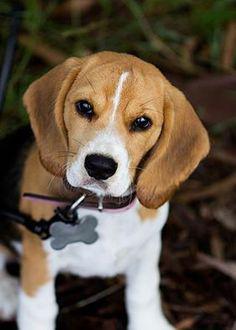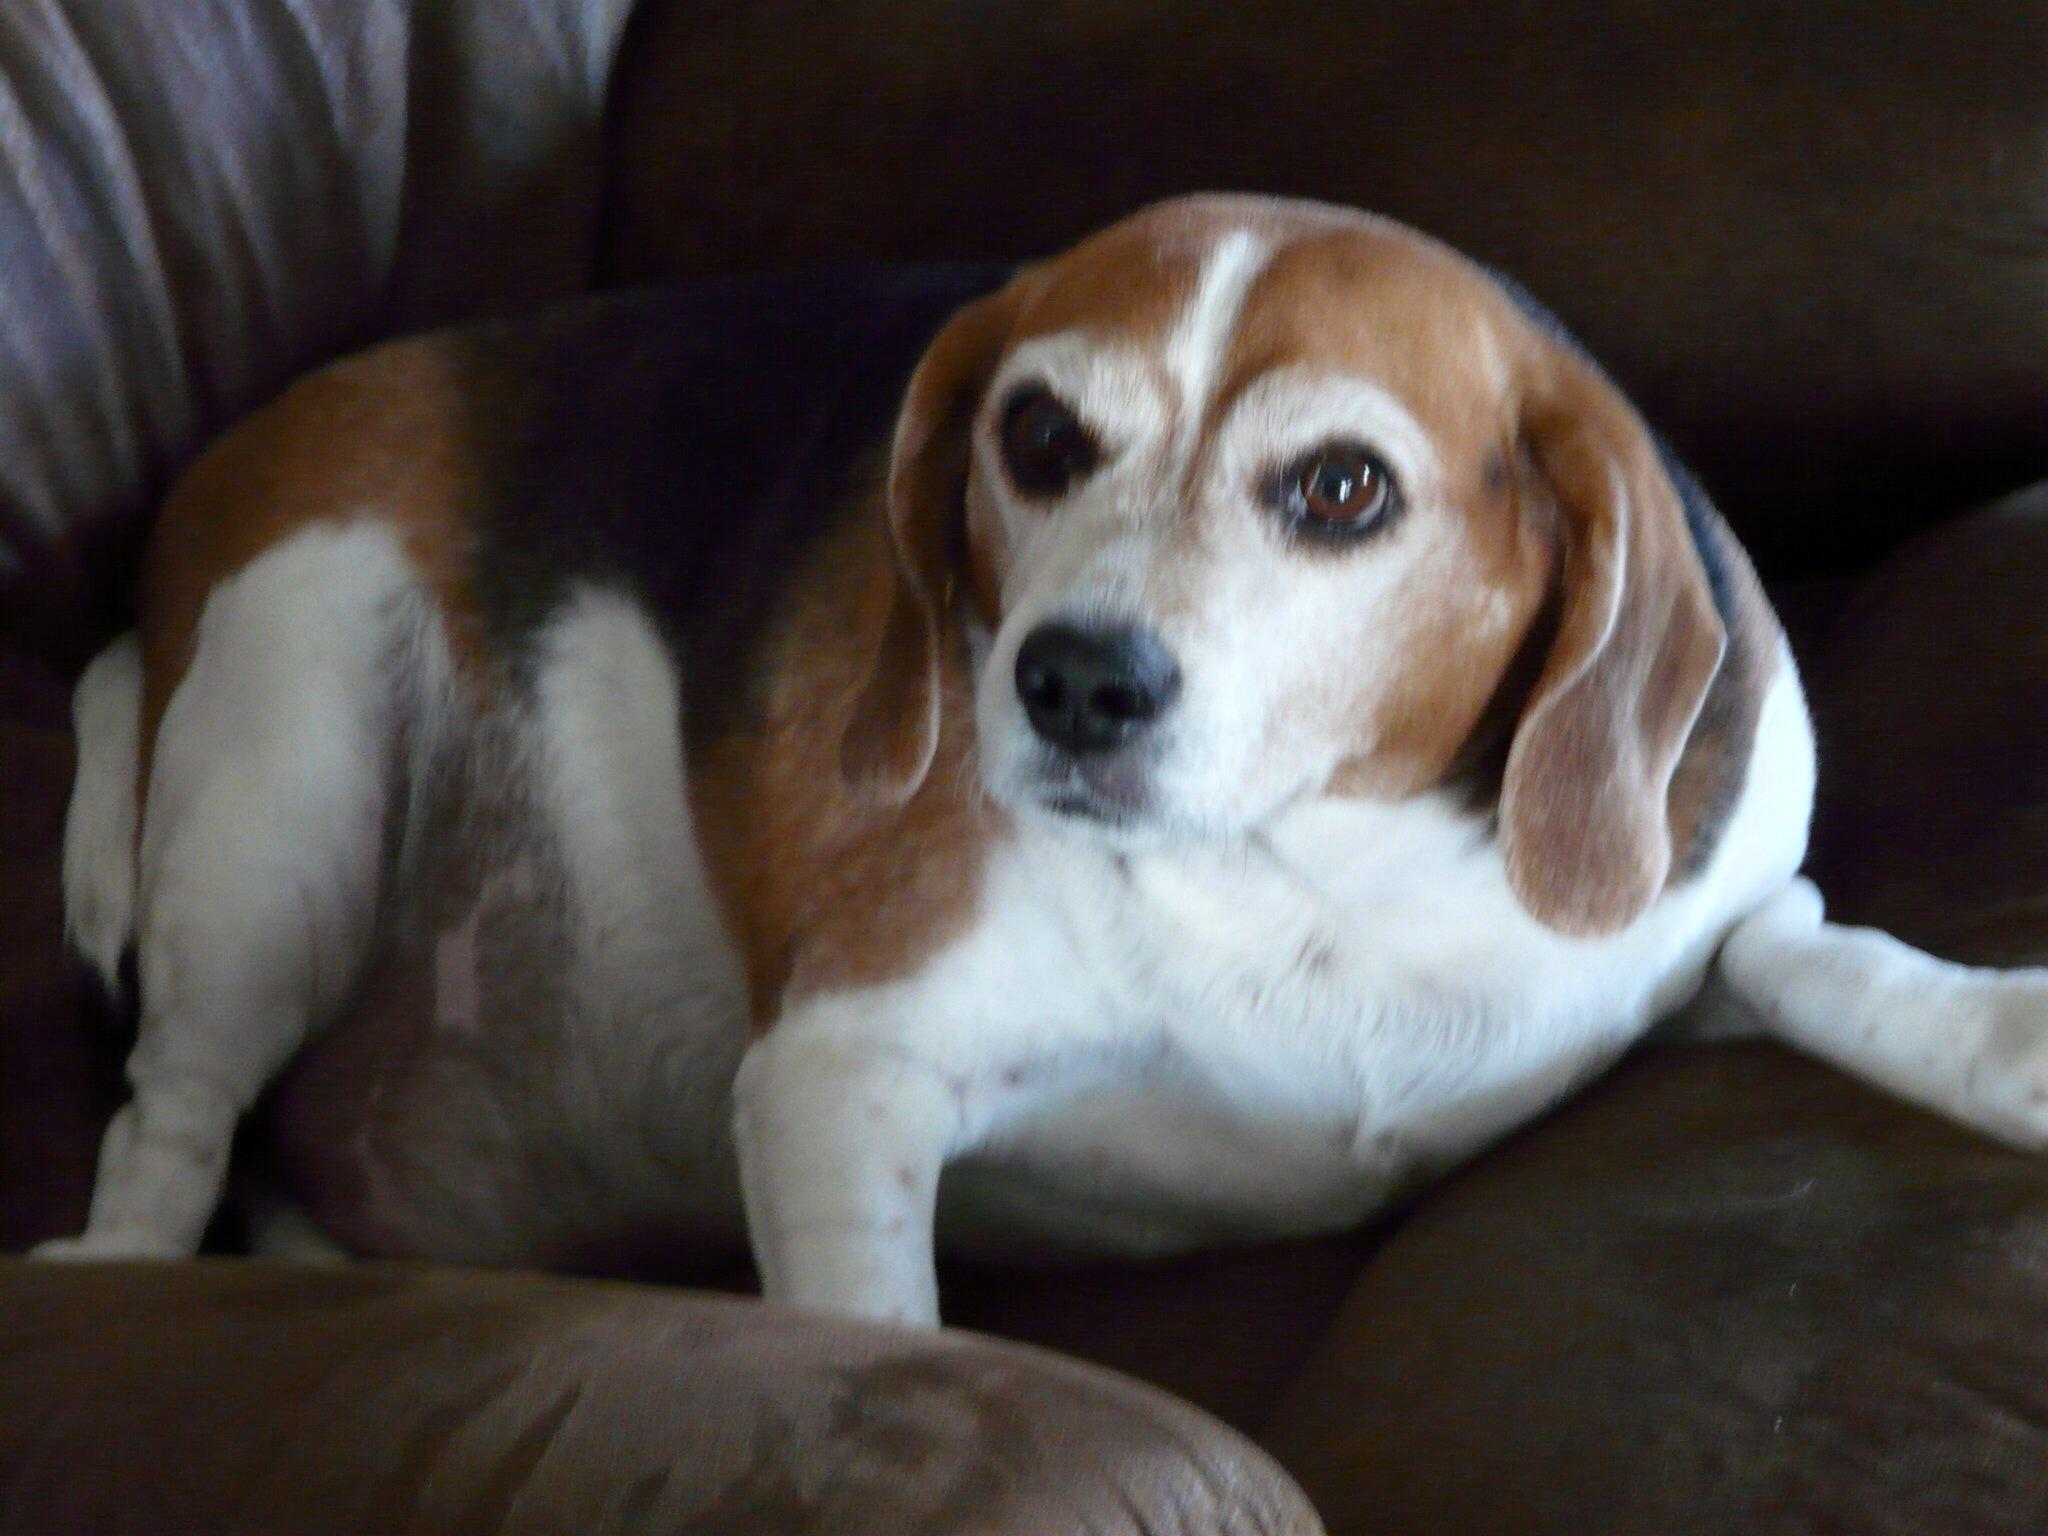The first image is the image on the left, the second image is the image on the right. Examine the images to the left and right. Is the description "There are at most two dogs." accurate? Answer yes or no. Yes. 